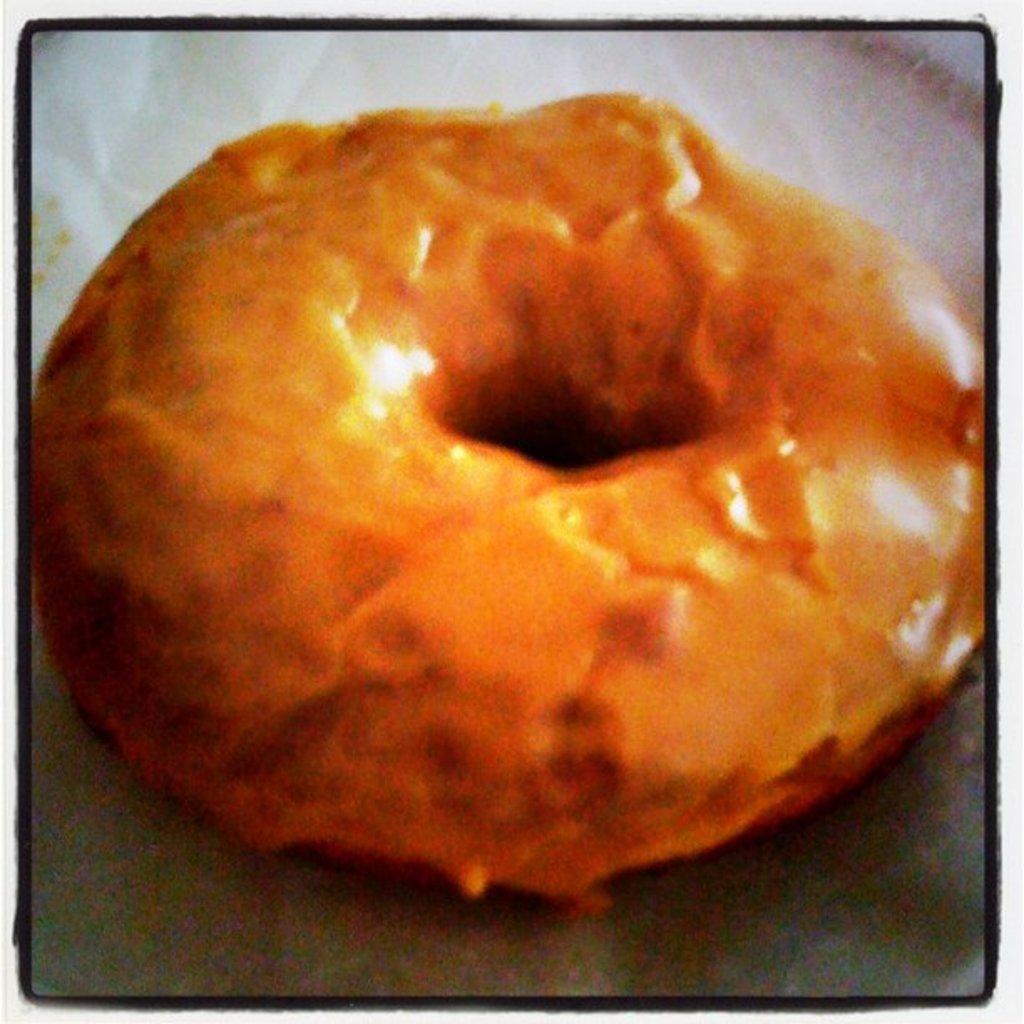Could you give a brief overview of what you see in this image? Here we can see a food item on a platform. 